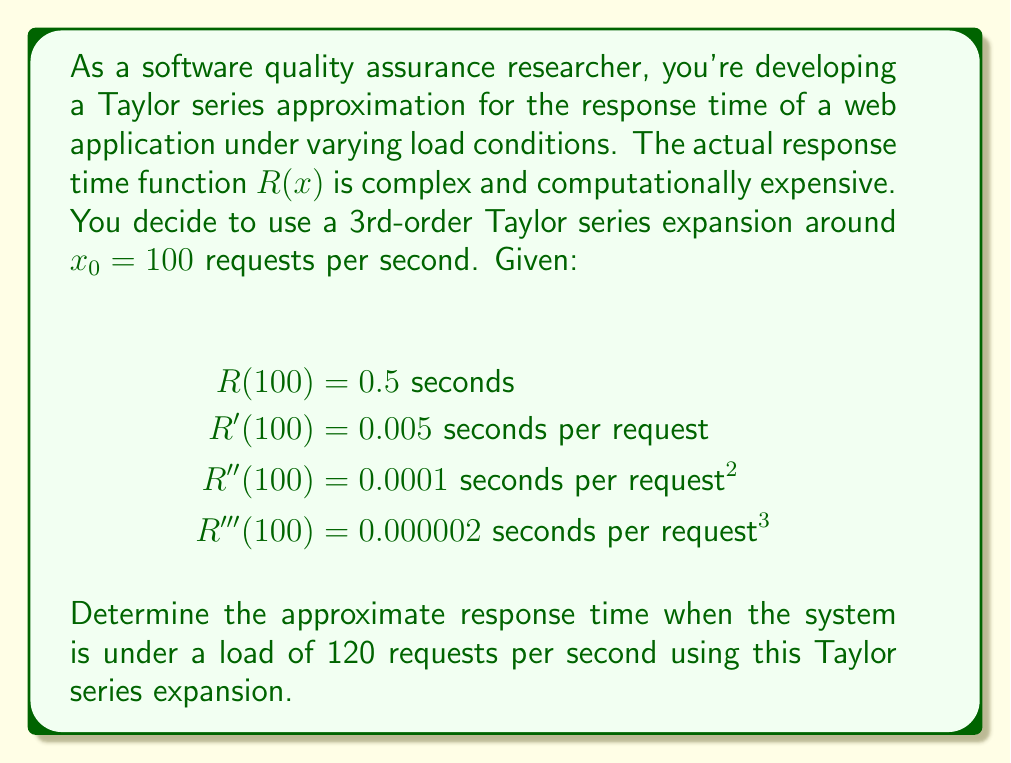Can you solve this math problem? To solve this problem, we'll use the Taylor series expansion formula up to the 3rd order:

$$R(x) \approx R(x_0) + R'(x_0)(x-x_0) + \frac{R''(x_0)}{2!}(x-x_0)^2 + \frac{R'''(x_0)}{3!}(x-x_0)^3$$

Where:
$x_0 = 100$ (expansion point)
$x = 120$ (point of interest)

Let's substitute the given values:

$$R(120) \approx 0.5 + 0.005(120-100) + \frac{0.0001}{2}(120-100)^2 + \frac{0.000002}{6}(120-100)^3$$

Now, let's calculate step by step:

1) $(120-100) = 20$
2) $(120-100)^2 = 400$
3) $(120-100)^3 = 8000$

Substituting these values:

$$R(120) \approx 0.5 + 0.005(20) + \frac{0.0001}{2}(400) + \frac{0.000002}{6}(8000)$$

Simplifying:

$$R(120) \approx 0.5 + 0.1 + 0.02 + \frac{0.016}{6}$$

$$R(120) \approx 0.5 + 0.1 + 0.02 + 0.00266667$$

Adding these terms:

$$R(120) \approx 0.62266667$$

Rounding to 4 decimal places for practical use:

$$R(120) \approx 0.6227 \text{ seconds}$$
Answer: The approximate response time when the system is under a load of 120 requests per second is 0.6227 seconds. 